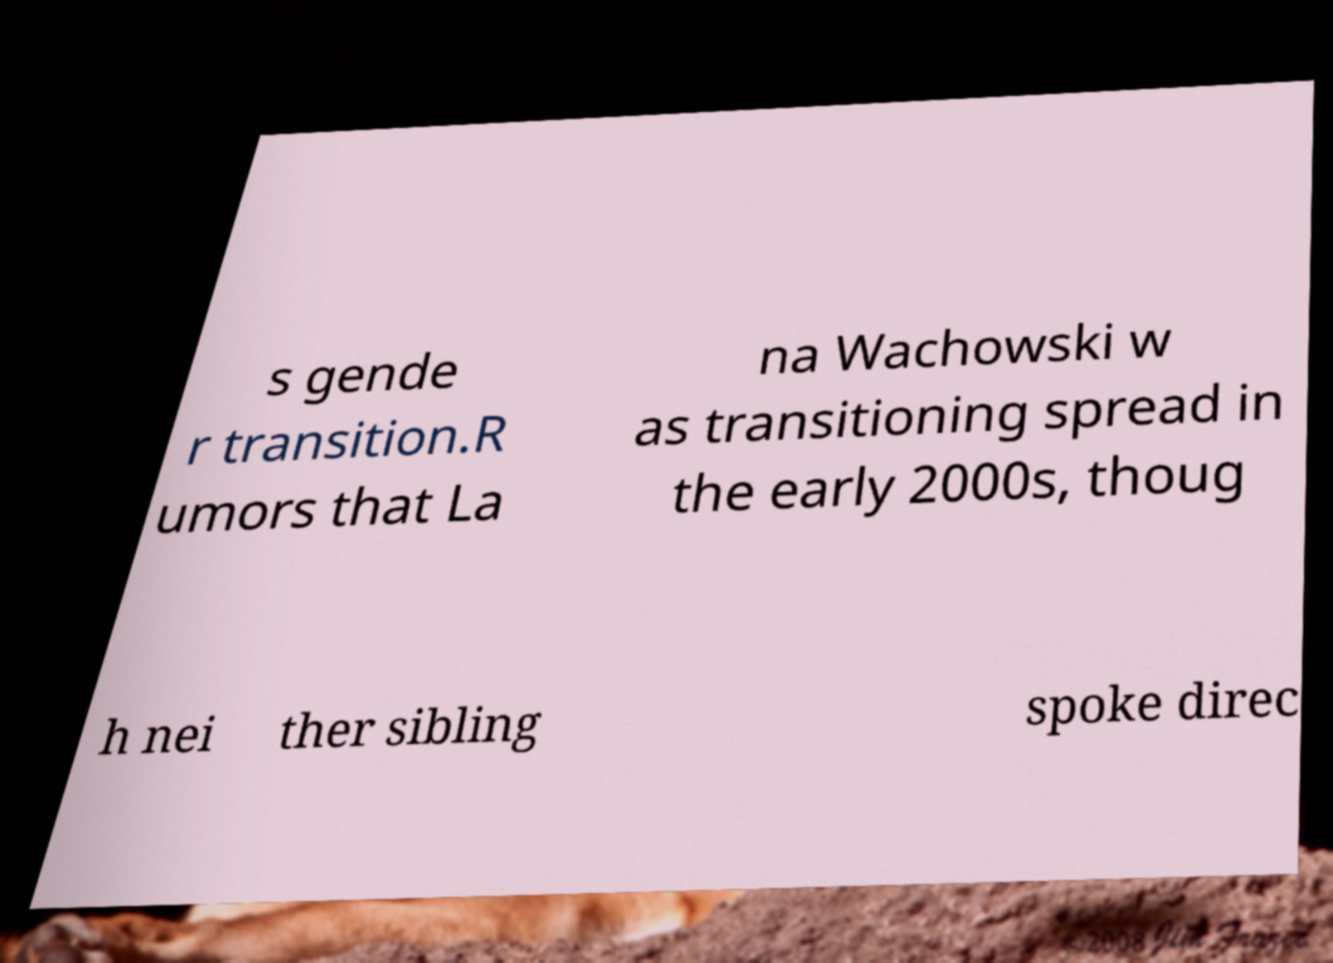For documentation purposes, I need the text within this image transcribed. Could you provide that? s gende r transition.R umors that La na Wachowski w as transitioning spread in the early 2000s, thoug h nei ther sibling spoke direc 